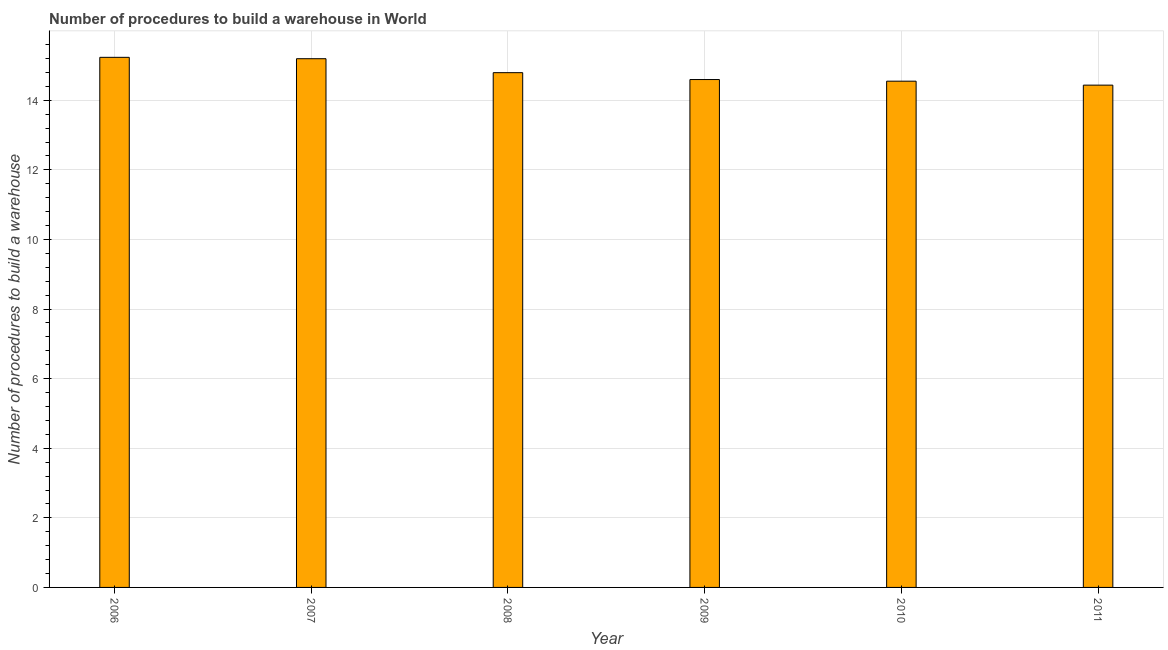Does the graph contain grids?
Ensure brevity in your answer.  Yes. What is the title of the graph?
Give a very brief answer. Number of procedures to build a warehouse in World. What is the label or title of the X-axis?
Keep it short and to the point. Year. What is the label or title of the Y-axis?
Your answer should be very brief. Number of procedures to build a warehouse. What is the number of procedures to build a warehouse in 2006?
Provide a short and direct response. 15.23. Across all years, what is the maximum number of procedures to build a warehouse?
Offer a terse response. 15.23. Across all years, what is the minimum number of procedures to build a warehouse?
Your answer should be compact. 14.44. In which year was the number of procedures to build a warehouse maximum?
Make the answer very short. 2006. In which year was the number of procedures to build a warehouse minimum?
Offer a very short reply. 2011. What is the sum of the number of procedures to build a warehouse?
Your answer should be compact. 88.81. What is the difference between the number of procedures to build a warehouse in 2008 and 2009?
Provide a short and direct response. 0.2. What is the average number of procedures to build a warehouse per year?
Provide a short and direct response. 14.8. What is the median number of procedures to build a warehouse?
Your answer should be very brief. 14.7. Do a majority of the years between 2011 and 2007 (inclusive) have number of procedures to build a warehouse greater than 7.6 ?
Your response must be concise. Yes. Is the difference between the number of procedures to build a warehouse in 2008 and 2011 greater than the difference between any two years?
Provide a succinct answer. No. Is the sum of the number of procedures to build a warehouse in 2006 and 2008 greater than the maximum number of procedures to build a warehouse across all years?
Give a very brief answer. Yes. In how many years, is the number of procedures to build a warehouse greater than the average number of procedures to build a warehouse taken over all years?
Keep it short and to the point. 2. How many bars are there?
Offer a very short reply. 6. Are all the bars in the graph horizontal?
Keep it short and to the point. No. Are the values on the major ticks of Y-axis written in scientific E-notation?
Provide a succinct answer. No. What is the Number of procedures to build a warehouse of 2006?
Provide a succinct answer. 15.23. What is the Number of procedures to build a warehouse in 2007?
Make the answer very short. 15.2. What is the Number of procedures to build a warehouse in 2008?
Ensure brevity in your answer.  14.79. What is the Number of procedures to build a warehouse in 2009?
Your answer should be very brief. 14.6. What is the Number of procedures to build a warehouse in 2010?
Your response must be concise. 14.55. What is the Number of procedures to build a warehouse in 2011?
Provide a succinct answer. 14.44. What is the difference between the Number of procedures to build a warehouse in 2006 and 2007?
Ensure brevity in your answer.  0.04. What is the difference between the Number of procedures to build a warehouse in 2006 and 2008?
Your answer should be compact. 0.44. What is the difference between the Number of procedures to build a warehouse in 2006 and 2009?
Your answer should be compact. 0.64. What is the difference between the Number of procedures to build a warehouse in 2006 and 2010?
Ensure brevity in your answer.  0.69. What is the difference between the Number of procedures to build a warehouse in 2006 and 2011?
Give a very brief answer. 0.8. What is the difference between the Number of procedures to build a warehouse in 2007 and 2008?
Your response must be concise. 0.4. What is the difference between the Number of procedures to build a warehouse in 2007 and 2009?
Keep it short and to the point. 0.6. What is the difference between the Number of procedures to build a warehouse in 2007 and 2010?
Offer a very short reply. 0.65. What is the difference between the Number of procedures to build a warehouse in 2007 and 2011?
Offer a terse response. 0.76. What is the difference between the Number of procedures to build a warehouse in 2008 and 2009?
Ensure brevity in your answer.  0.2. What is the difference between the Number of procedures to build a warehouse in 2008 and 2010?
Your answer should be very brief. 0.24. What is the difference between the Number of procedures to build a warehouse in 2008 and 2011?
Provide a short and direct response. 0.36. What is the difference between the Number of procedures to build a warehouse in 2009 and 2010?
Your answer should be compact. 0.05. What is the difference between the Number of procedures to build a warehouse in 2009 and 2011?
Keep it short and to the point. 0.16. What is the difference between the Number of procedures to build a warehouse in 2010 and 2011?
Offer a terse response. 0.11. What is the ratio of the Number of procedures to build a warehouse in 2006 to that in 2008?
Keep it short and to the point. 1.03. What is the ratio of the Number of procedures to build a warehouse in 2006 to that in 2009?
Your answer should be very brief. 1.04. What is the ratio of the Number of procedures to build a warehouse in 2006 to that in 2010?
Give a very brief answer. 1.05. What is the ratio of the Number of procedures to build a warehouse in 2006 to that in 2011?
Make the answer very short. 1.05. What is the ratio of the Number of procedures to build a warehouse in 2007 to that in 2009?
Make the answer very short. 1.04. What is the ratio of the Number of procedures to build a warehouse in 2007 to that in 2010?
Offer a very short reply. 1.04. What is the ratio of the Number of procedures to build a warehouse in 2007 to that in 2011?
Your answer should be very brief. 1.05. What is the ratio of the Number of procedures to build a warehouse in 2008 to that in 2010?
Keep it short and to the point. 1.02. What is the ratio of the Number of procedures to build a warehouse in 2009 to that in 2010?
Provide a short and direct response. 1. What is the ratio of the Number of procedures to build a warehouse in 2010 to that in 2011?
Offer a very short reply. 1.01. 